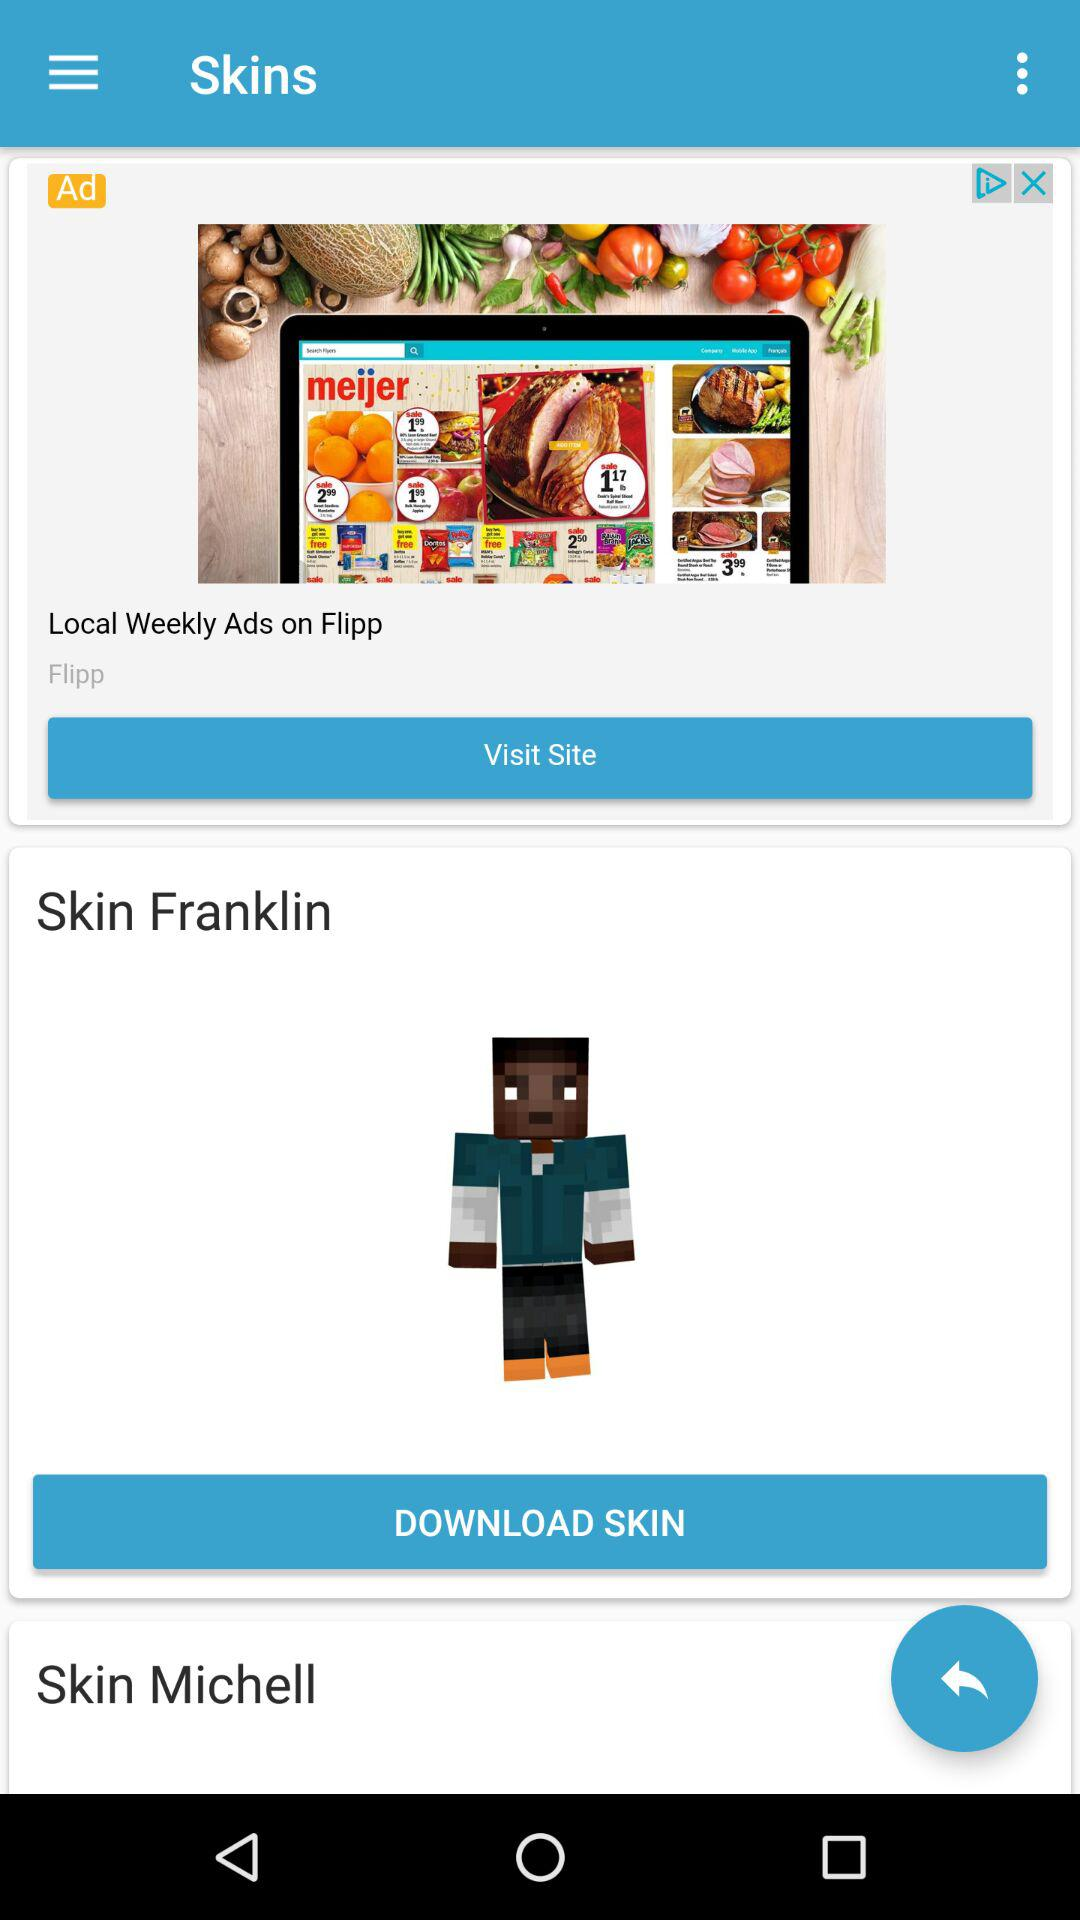What is the application name in the advertisement? The application name in the advertisement is "Flipp". 